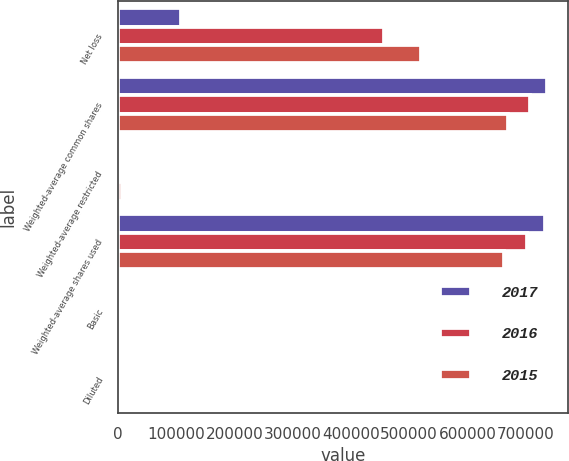Convert chart to OTSL. <chart><loc_0><loc_0><loc_500><loc_500><stacked_bar_chart><ecel><fcel>Net loss<fcel>Weighted-average common shares<fcel>Weighted-average restricted<fcel>Weighted-average shares used<fcel>Basic<fcel>Diluted<nl><fcel>2017<fcel>108063<fcel>736607<fcel>3905<fcel>732702<fcel>0.15<fcel>0.15<nl><fcel>2016<fcel>456873<fcel>708010<fcel>5875<fcel>702135<fcel>0.65<fcel>0.65<nl><fcel>2015<fcel>521031<fcel>670132<fcel>7708<fcel>662424<fcel>0.79<fcel>0.79<nl></chart> 